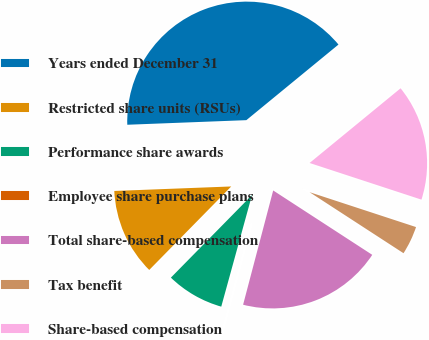Convert chart to OTSL. <chart><loc_0><loc_0><loc_500><loc_500><pie_chart><fcel>Years ended December 31<fcel>Restricted share units (RSUs)<fcel>Performance share awards<fcel>Employee share purchase plans<fcel>Total share-based compensation<fcel>Tax benefit<fcel>Share-based compensation<nl><fcel>39.68%<fcel>12.03%<fcel>8.08%<fcel>0.18%<fcel>19.93%<fcel>4.13%<fcel>15.98%<nl></chart> 